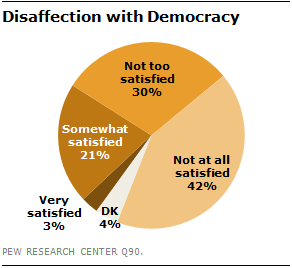Give some essential details in this illustration. The value of the "Very satisfied" segment is 3%. Yes. The result of taking the sum of the two smallest segments and multiplying it by 3 is equal to the third largest segment if the answer is "yes. 